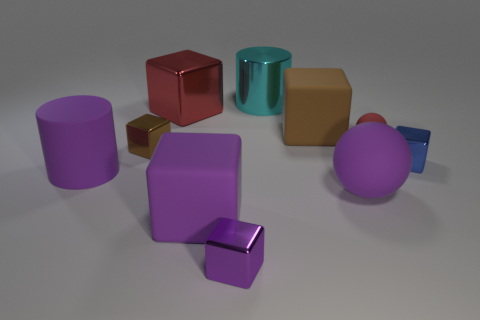What size is the brown matte object that is the same shape as the blue thing?
Provide a short and direct response. Large. What number of other things are made of the same material as the big cyan cylinder?
Your answer should be very brief. 4. What material is the small blue object?
Give a very brief answer. Metal. There is a small cube that is in front of the blue block; does it have the same color as the rubber block in front of the large rubber ball?
Provide a short and direct response. Yes. Are there more brown cubes in front of the tiny red object than small blue spheres?
Ensure brevity in your answer.  Yes. What number of other objects are there of the same color as the big metallic cube?
Keep it short and to the point. 1. There is a cube that is behind the brown rubber cube; does it have the same size as the big cyan metallic cylinder?
Your answer should be compact. Yes. Are there any red metal blocks that have the same size as the cyan cylinder?
Keep it short and to the point. Yes. What is the color of the large cube that is in front of the purple rubber cylinder?
Make the answer very short. Purple. What is the shape of the object that is both on the right side of the big brown block and in front of the matte cylinder?
Give a very brief answer. Sphere. 